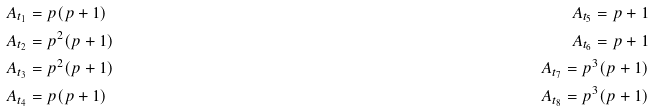Convert formula to latex. <formula><loc_0><loc_0><loc_500><loc_500>A _ { t _ { 1 } } & = p ( p + 1 ) & A _ { t _ { 5 } } = p + 1 \\ A _ { t _ { 2 } } & = p ^ { 2 } ( p + 1 ) & A _ { t _ { 6 } } = p + 1 \\ A _ { t _ { 3 } } & = p ^ { 2 } ( p + 1 ) & A _ { t _ { 7 } } = p ^ { 3 } ( p + 1 ) \\ A _ { t _ { 4 } } & = p ( p + 1 ) & A _ { t _ { 8 } } = p ^ { 3 } ( p + 1 )</formula> 